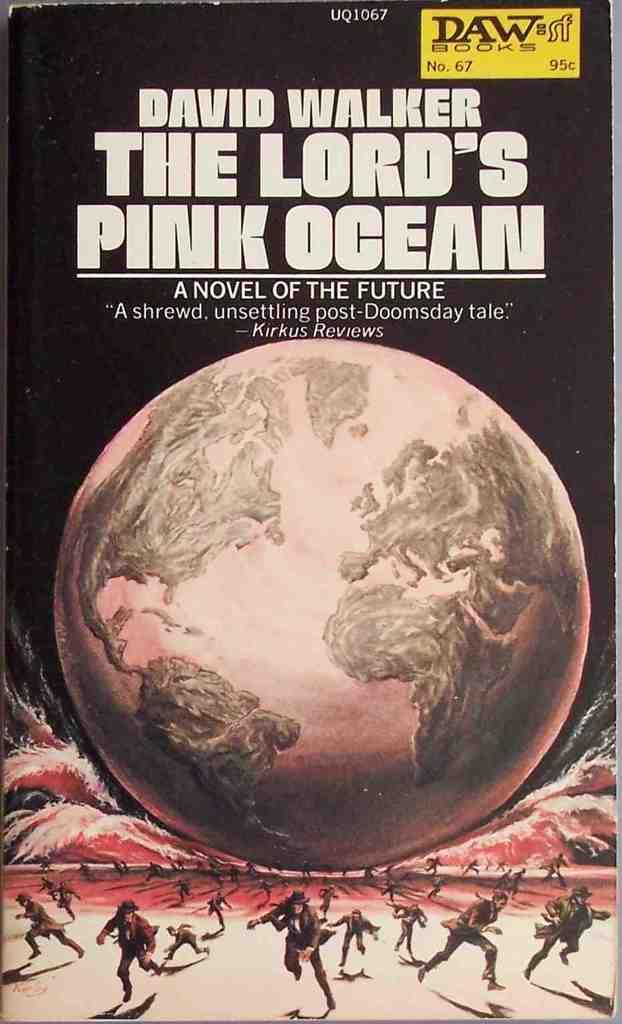<image>
Offer a succinct explanation of the picture presented. The cover of the novel "The Lord's Pink Ocean" that shows a pink globe seeming to crush people who are running away. 